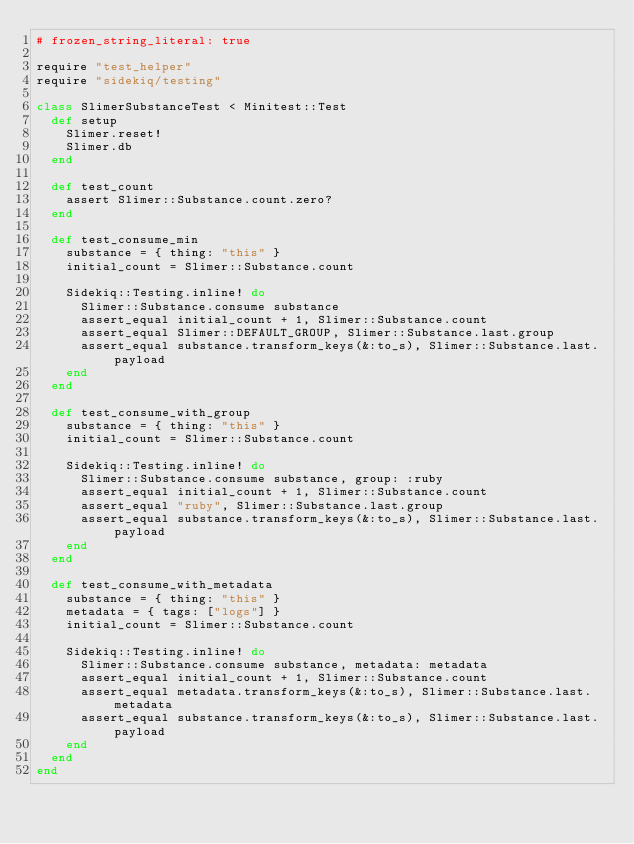<code> <loc_0><loc_0><loc_500><loc_500><_Ruby_># frozen_string_literal: true

require "test_helper"
require "sidekiq/testing"

class SlimerSubstanceTest < Minitest::Test
  def setup
    Slimer.reset!
    Slimer.db
  end

  def test_count
    assert Slimer::Substance.count.zero?
  end

  def test_consume_min
    substance = { thing: "this" }
    initial_count = Slimer::Substance.count

    Sidekiq::Testing.inline! do
      Slimer::Substance.consume substance
      assert_equal initial_count + 1, Slimer::Substance.count
      assert_equal Slimer::DEFAULT_GROUP, Slimer::Substance.last.group
      assert_equal substance.transform_keys(&:to_s), Slimer::Substance.last.payload
    end
  end

  def test_consume_with_group
    substance = { thing: "this" }
    initial_count = Slimer::Substance.count

    Sidekiq::Testing.inline! do
      Slimer::Substance.consume substance, group: :ruby
      assert_equal initial_count + 1, Slimer::Substance.count
      assert_equal "ruby", Slimer::Substance.last.group
      assert_equal substance.transform_keys(&:to_s), Slimer::Substance.last.payload
    end
  end

  def test_consume_with_metadata
    substance = { thing: "this" }
    metadata = { tags: ["logs"] }
    initial_count = Slimer::Substance.count

    Sidekiq::Testing.inline! do
      Slimer::Substance.consume substance, metadata: metadata
      assert_equal initial_count + 1, Slimer::Substance.count
      assert_equal metadata.transform_keys(&:to_s), Slimer::Substance.last.metadata
      assert_equal substance.transform_keys(&:to_s), Slimer::Substance.last.payload
    end
  end
end
</code> 